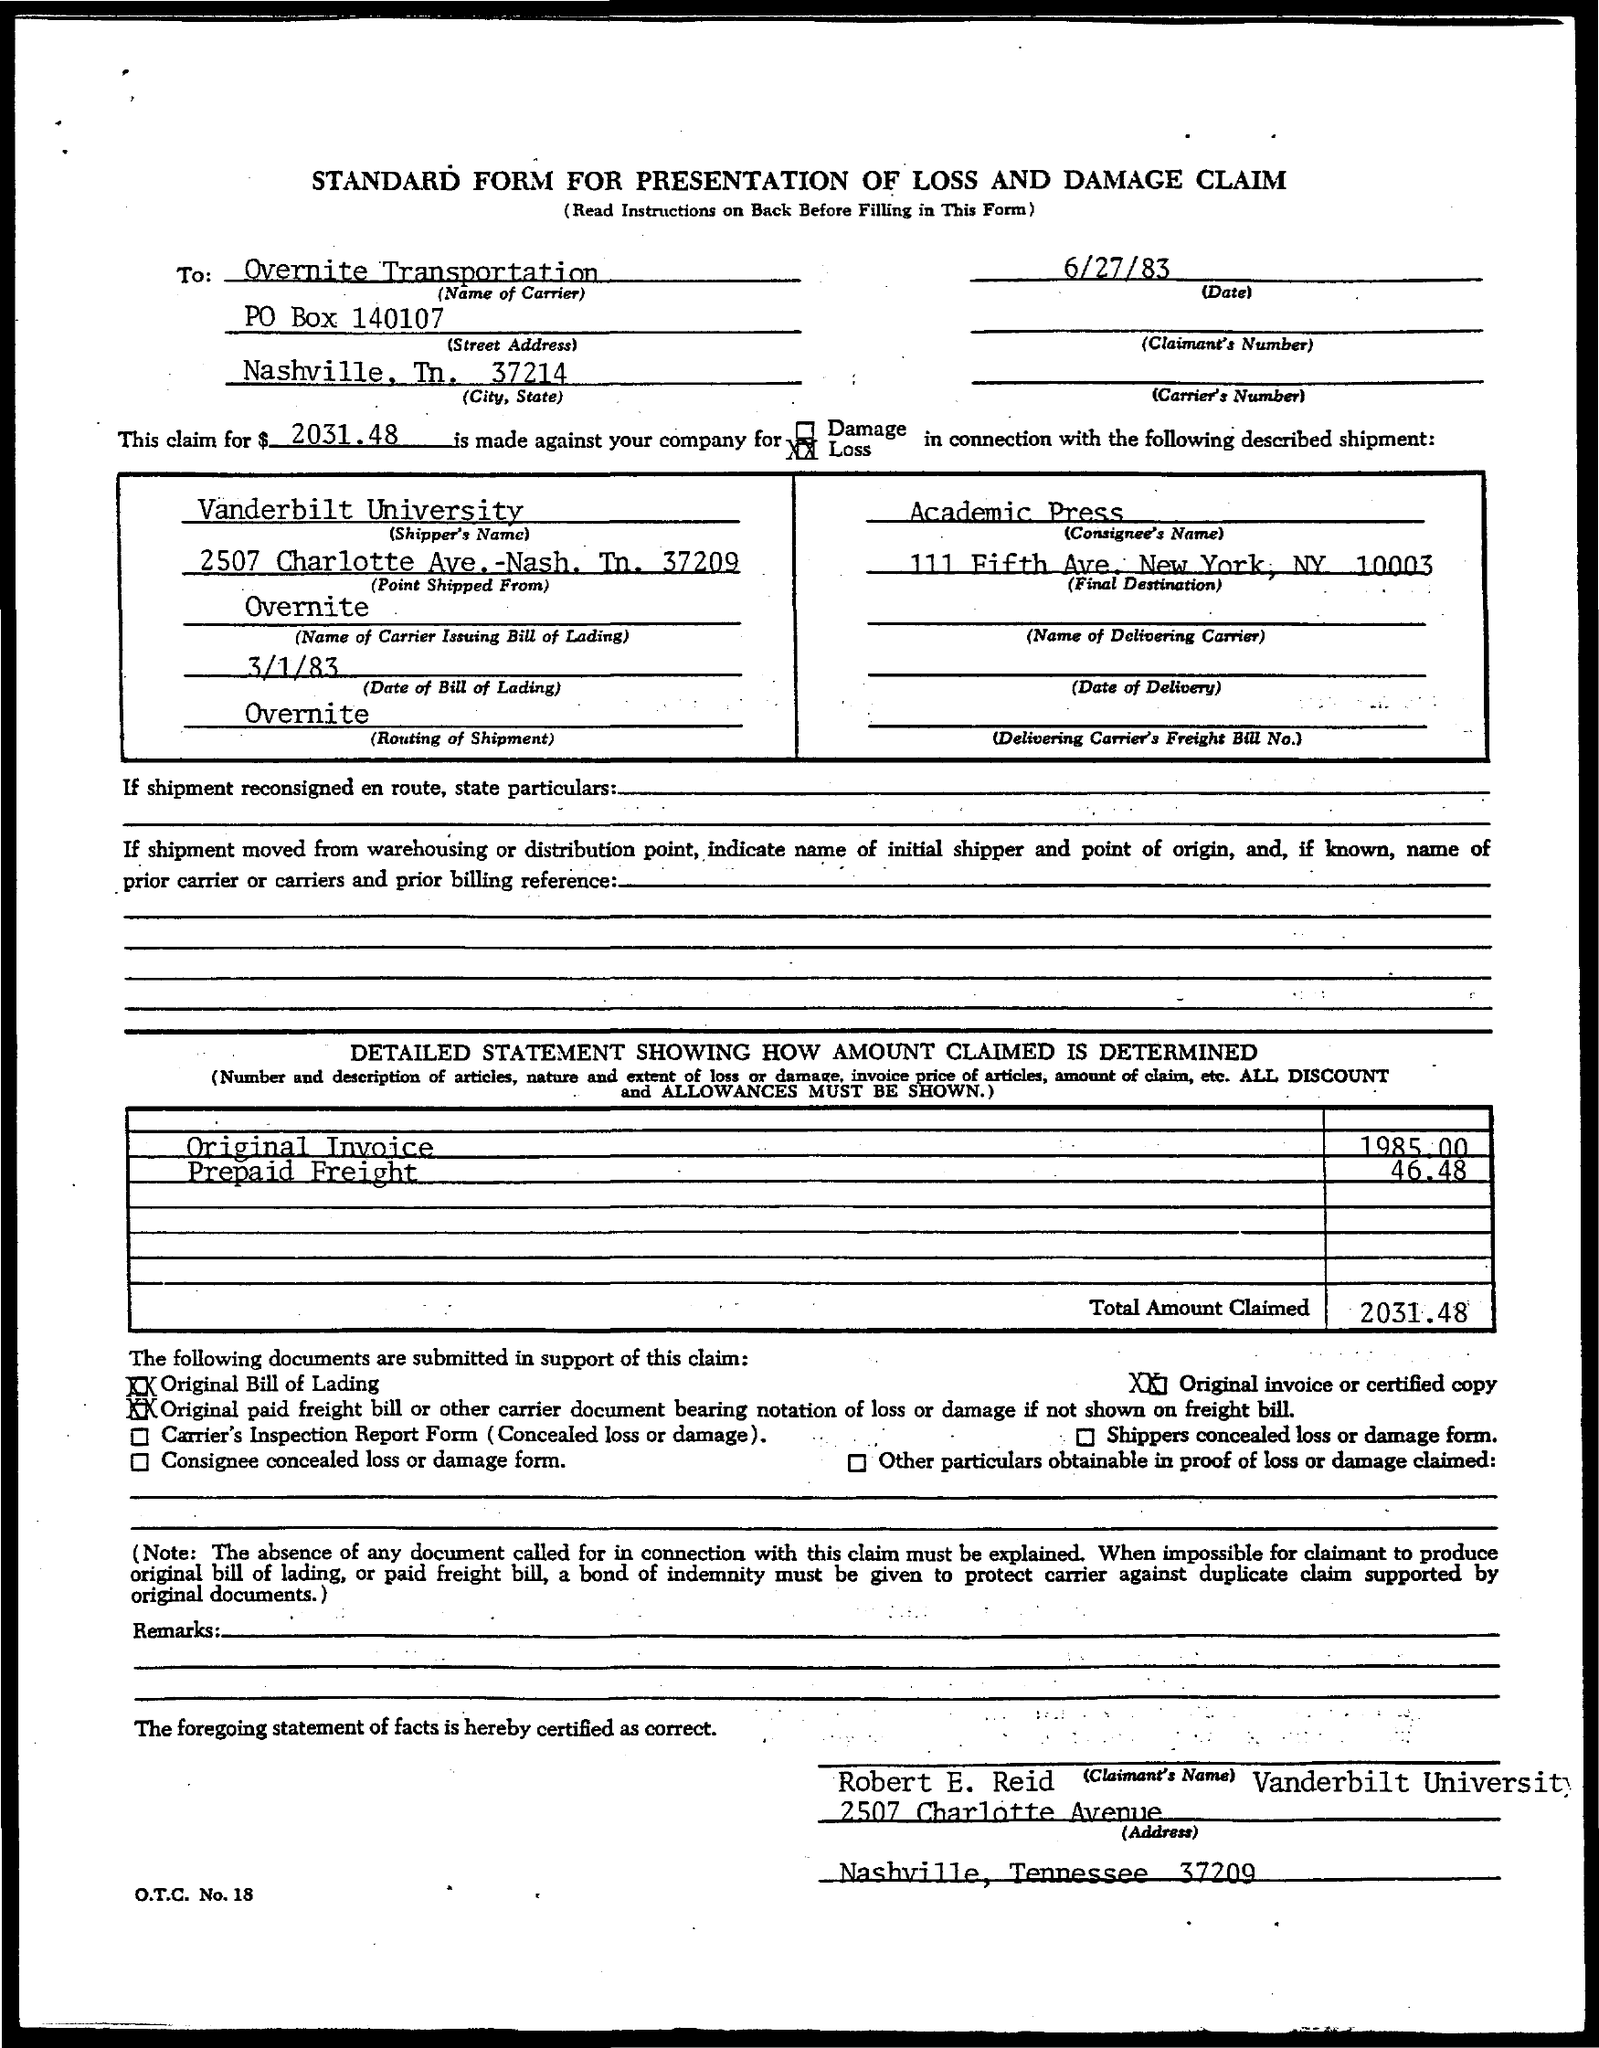What is the name of the carrier?
Give a very brief answer. Overnite Transportation. What is the street address?
Give a very brief answer. PO Box 140107. What is the City, State?
Provide a succinct answer. Nashville, tn. 37214. What is the Date?
Your response must be concise. 6/27/83. What is the Shipper's Name?
Give a very brief answer. Vanderbilt University. What is the date of bill of loading?
Your answer should be compact. 3/1/83. What is the consigner's name?
Your answer should be compact. Academic press. What is the final destination?
Make the answer very short. 111 fifth ave. new york, ny 10003. What is the Total amount claimed?
Your response must be concise. 2031.48. What is the Original Invoice amount?
Offer a very short reply. 1985.00. 